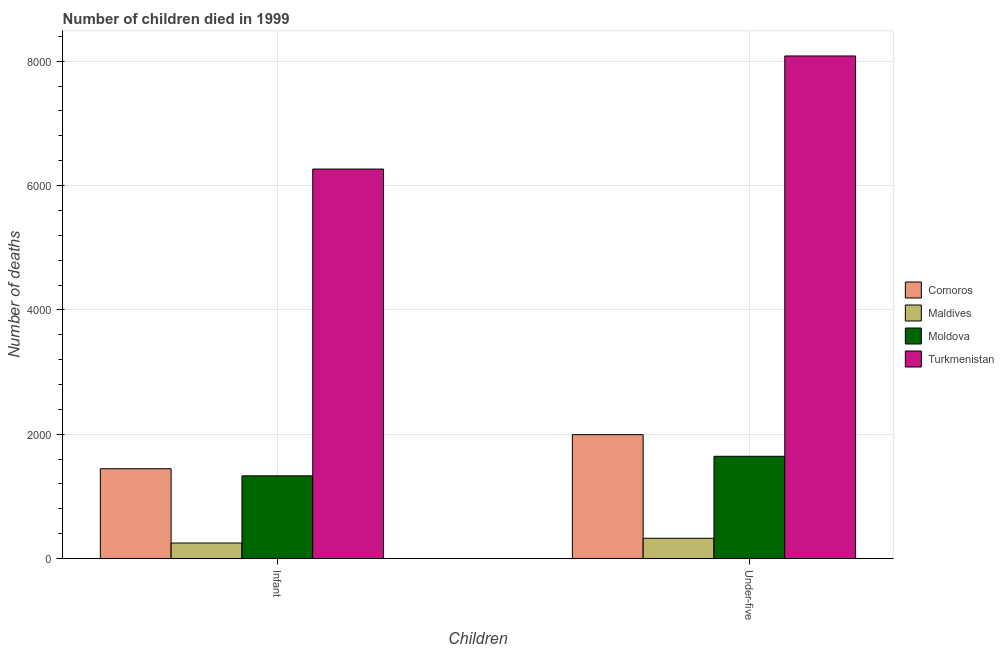How many groups of bars are there?
Your answer should be very brief. 2. Are the number of bars per tick equal to the number of legend labels?
Ensure brevity in your answer.  Yes. How many bars are there on the 2nd tick from the left?
Your answer should be compact. 4. What is the label of the 1st group of bars from the left?
Provide a short and direct response. Infant. What is the number of under-five deaths in Turkmenistan?
Ensure brevity in your answer.  8084. Across all countries, what is the maximum number of infant deaths?
Provide a short and direct response. 6265. Across all countries, what is the minimum number of under-five deaths?
Provide a succinct answer. 327. In which country was the number of under-five deaths maximum?
Offer a terse response. Turkmenistan. In which country was the number of infant deaths minimum?
Offer a very short reply. Maldives. What is the total number of infant deaths in the graph?
Make the answer very short. 9291. What is the difference between the number of under-five deaths in Comoros and that in Turkmenistan?
Your answer should be very brief. -6091. What is the difference between the number of under-five deaths in Moldova and the number of infant deaths in Comoros?
Ensure brevity in your answer.  200. What is the average number of infant deaths per country?
Offer a very short reply. 2322.75. What is the difference between the number of under-five deaths and number of infant deaths in Turkmenistan?
Offer a terse response. 1819. What is the ratio of the number of under-five deaths in Maldives to that in Moldova?
Offer a terse response. 0.2. In how many countries, is the number of under-five deaths greater than the average number of under-five deaths taken over all countries?
Offer a terse response. 1. What does the 3rd bar from the left in Infant represents?
Your answer should be compact. Moldova. What does the 1st bar from the right in Under-five represents?
Ensure brevity in your answer.  Turkmenistan. Are all the bars in the graph horizontal?
Give a very brief answer. No. What is the difference between two consecutive major ticks on the Y-axis?
Give a very brief answer. 2000. Are the values on the major ticks of Y-axis written in scientific E-notation?
Your answer should be compact. No. Does the graph contain grids?
Provide a succinct answer. Yes. What is the title of the graph?
Make the answer very short. Number of children died in 1999. Does "Argentina" appear as one of the legend labels in the graph?
Provide a succinct answer. No. What is the label or title of the X-axis?
Keep it short and to the point. Children. What is the label or title of the Y-axis?
Give a very brief answer. Number of deaths. What is the Number of deaths of Comoros in Infant?
Provide a succinct answer. 1445. What is the Number of deaths in Maldives in Infant?
Ensure brevity in your answer.  250. What is the Number of deaths in Moldova in Infant?
Provide a succinct answer. 1331. What is the Number of deaths of Turkmenistan in Infant?
Ensure brevity in your answer.  6265. What is the Number of deaths of Comoros in Under-five?
Your response must be concise. 1993. What is the Number of deaths in Maldives in Under-five?
Offer a very short reply. 327. What is the Number of deaths in Moldova in Under-five?
Offer a very short reply. 1645. What is the Number of deaths of Turkmenistan in Under-five?
Your response must be concise. 8084. Across all Children, what is the maximum Number of deaths of Comoros?
Your answer should be compact. 1993. Across all Children, what is the maximum Number of deaths of Maldives?
Offer a terse response. 327. Across all Children, what is the maximum Number of deaths of Moldova?
Make the answer very short. 1645. Across all Children, what is the maximum Number of deaths of Turkmenistan?
Your answer should be very brief. 8084. Across all Children, what is the minimum Number of deaths in Comoros?
Keep it short and to the point. 1445. Across all Children, what is the minimum Number of deaths in Maldives?
Give a very brief answer. 250. Across all Children, what is the minimum Number of deaths in Moldova?
Make the answer very short. 1331. Across all Children, what is the minimum Number of deaths of Turkmenistan?
Provide a succinct answer. 6265. What is the total Number of deaths in Comoros in the graph?
Your answer should be very brief. 3438. What is the total Number of deaths in Maldives in the graph?
Make the answer very short. 577. What is the total Number of deaths in Moldova in the graph?
Make the answer very short. 2976. What is the total Number of deaths of Turkmenistan in the graph?
Keep it short and to the point. 1.43e+04. What is the difference between the Number of deaths in Comoros in Infant and that in Under-five?
Your response must be concise. -548. What is the difference between the Number of deaths of Maldives in Infant and that in Under-five?
Provide a succinct answer. -77. What is the difference between the Number of deaths of Moldova in Infant and that in Under-five?
Provide a short and direct response. -314. What is the difference between the Number of deaths of Turkmenistan in Infant and that in Under-five?
Your answer should be compact. -1819. What is the difference between the Number of deaths in Comoros in Infant and the Number of deaths in Maldives in Under-five?
Ensure brevity in your answer.  1118. What is the difference between the Number of deaths in Comoros in Infant and the Number of deaths in Moldova in Under-five?
Your answer should be very brief. -200. What is the difference between the Number of deaths in Comoros in Infant and the Number of deaths in Turkmenistan in Under-five?
Provide a succinct answer. -6639. What is the difference between the Number of deaths in Maldives in Infant and the Number of deaths in Moldova in Under-five?
Provide a succinct answer. -1395. What is the difference between the Number of deaths of Maldives in Infant and the Number of deaths of Turkmenistan in Under-five?
Your answer should be compact. -7834. What is the difference between the Number of deaths of Moldova in Infant and the Number of deaths of Turkmenistan in Under-five?
Give a very brief answer. -6753. What is the average Number of deaths of Comoros per Children?
Offer a terse response. 1719. What is the average Number of deaths in Maldives per Children?
Your answer should be compact. 288.5. What is the average Number of deaths of Moldova per Children?
Offer a very short reply. 1488. What is the average Number of deaths in Turkmenistan per Children?
Make the answer very short. 7174.5. What is the difference between the Number of deaths of Comoros and Number of deaths of Maldives in Infant?
Keep it short and to the point. 1195. What is the difference between the Number of deaths of Comoros and Number of deaths of Moldova in Infant?
Your answer should be very brief. 114. What is the difference between the Number of deaths of Comoros and Number of deaths of Turkmenistan in Infant?
Keep it short and to the point. -4820. What is the difference between the Number of deaths in Maldives and Number of deaths in Moldova in Infant?
Make the answer very short. -1081. What is the difference between the Number of deaths in Maldives and Number of deaths in Turkmenistan in Infant?
Provide a succinct answer. -6015. What is the difference between the Number of deaths in Moldova and Number of deaths in Turkmenistan in Infant?
Ensure brevity in your answer.  -4934. What is the difference between the Number of deaths of Comoros and Number of deaths of Maldives in Under-five?
Make the answer very short. 1666. What is the difference between the Number of deaths in Comoros and Number of deaths in Moldova in Under-five?
Provide a short and direct response. 348. What is the difference between the Number of deaths of Comoros and Number of deaths of Turkmenistan in Under-five?
Your answer should be compact. -6091. What is the difference between the Number of deaths of Maldives and Number of deaths of Moldova in Under-five?
Provide a succinct answer. -1318. What is the difference between the Number of deaths of Maldives and Number of deaths of Turkmenistan in Under-five?
Your answer should be compact. -7757. What is the difference between the Number of deaths of Moldova and Number of deaths of Turkmenistan in Under-five?
Offer a very short reply. -6439. What is the ratio of the Number of deaths of Comoros in Infant to that in Under-five?
Give a very brief answer. 0.72. What is the ratio of the Number of deaths of Maldives in Infant to that in Under-five?
Offer a terse response. 0.76. What is the ratio of the Number of deaths in Moldova in Infant to that in Under-five?
Ensure brevity in your answer.  0.81. What is the ratio of the Number of deaths of Turkmenistan in Infant to that in Under-five?
Your answer should be very brief. 0.78. What is the difference between the highest and the second highest Number of deaths of Comoros?
Provide a short and direct response. 548. What is the difference between the highest and the second highest Number of deaths in Moldova?
Your response must be concise. 314. What is the difference between the highest and the second highest Number of deaths of Turkmenistan?
Keep it short and to the point. 1819. What is the difference between the highest and the lowest Number of deaths of Comoros?
Keep it short and to the point. 548. What is the difference between the highest and the lowest Number of deaths in Moldova?
Make the answer very short. 314. What is the difference between the highest and the lowest Number of deaths in Turkmenistan?
Provide a short and direct response. 1819. 